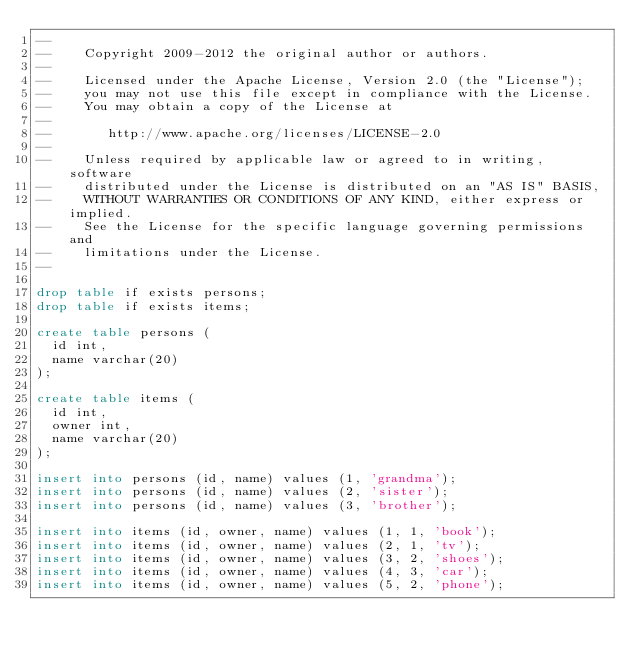Convert code to text. <code><loc_0><loc_0><loc_500><loc_500><_SQL_>--
--    Copyright 2009-2012 the original author or authors.
--
--    Licensed under the Apache License, Version 2.0 (the "License");
--    you may not use this file except in compliance with the License.
--    You may obtain a copy of the License at
--
--       http://www.apache.org/licenses/LICENSE-2.0
--
--    Unless required by applicable law or agreed to in writing, software
--    distributed under the License is distributed on an "AS IS" BASIS,
--    WITHOUT WARRANTIES OR CONDITIONS OF ANY KIND, either express or implied.
--    See the License for the specific language governing permissions and
--    limitations under the License.
--

drop table if exists persons;
drop table if exists items;

create table persons (
  id int,
  name varchar(20)
);

create table items (
  id int,
  owner int,
  name varchar(20)
);
 
insert into persons (id, name) values (1, 'grandma');
insert into persons (id, name) values (2, 'sister');
insert into persons (id, name) values (3, 'brother');

insert into items (id, owner, name) values (1, 1, 'book');
insert into items (id, owner, name) values (2, 1, 'tv');
insert into items (id, owner, name) values (3, 2, 'shoes');
insert into items (id, owner, name) values (4, 3, 'car');
insert into items (id, owner, name) values (5, 2, 'phone');
</code> 